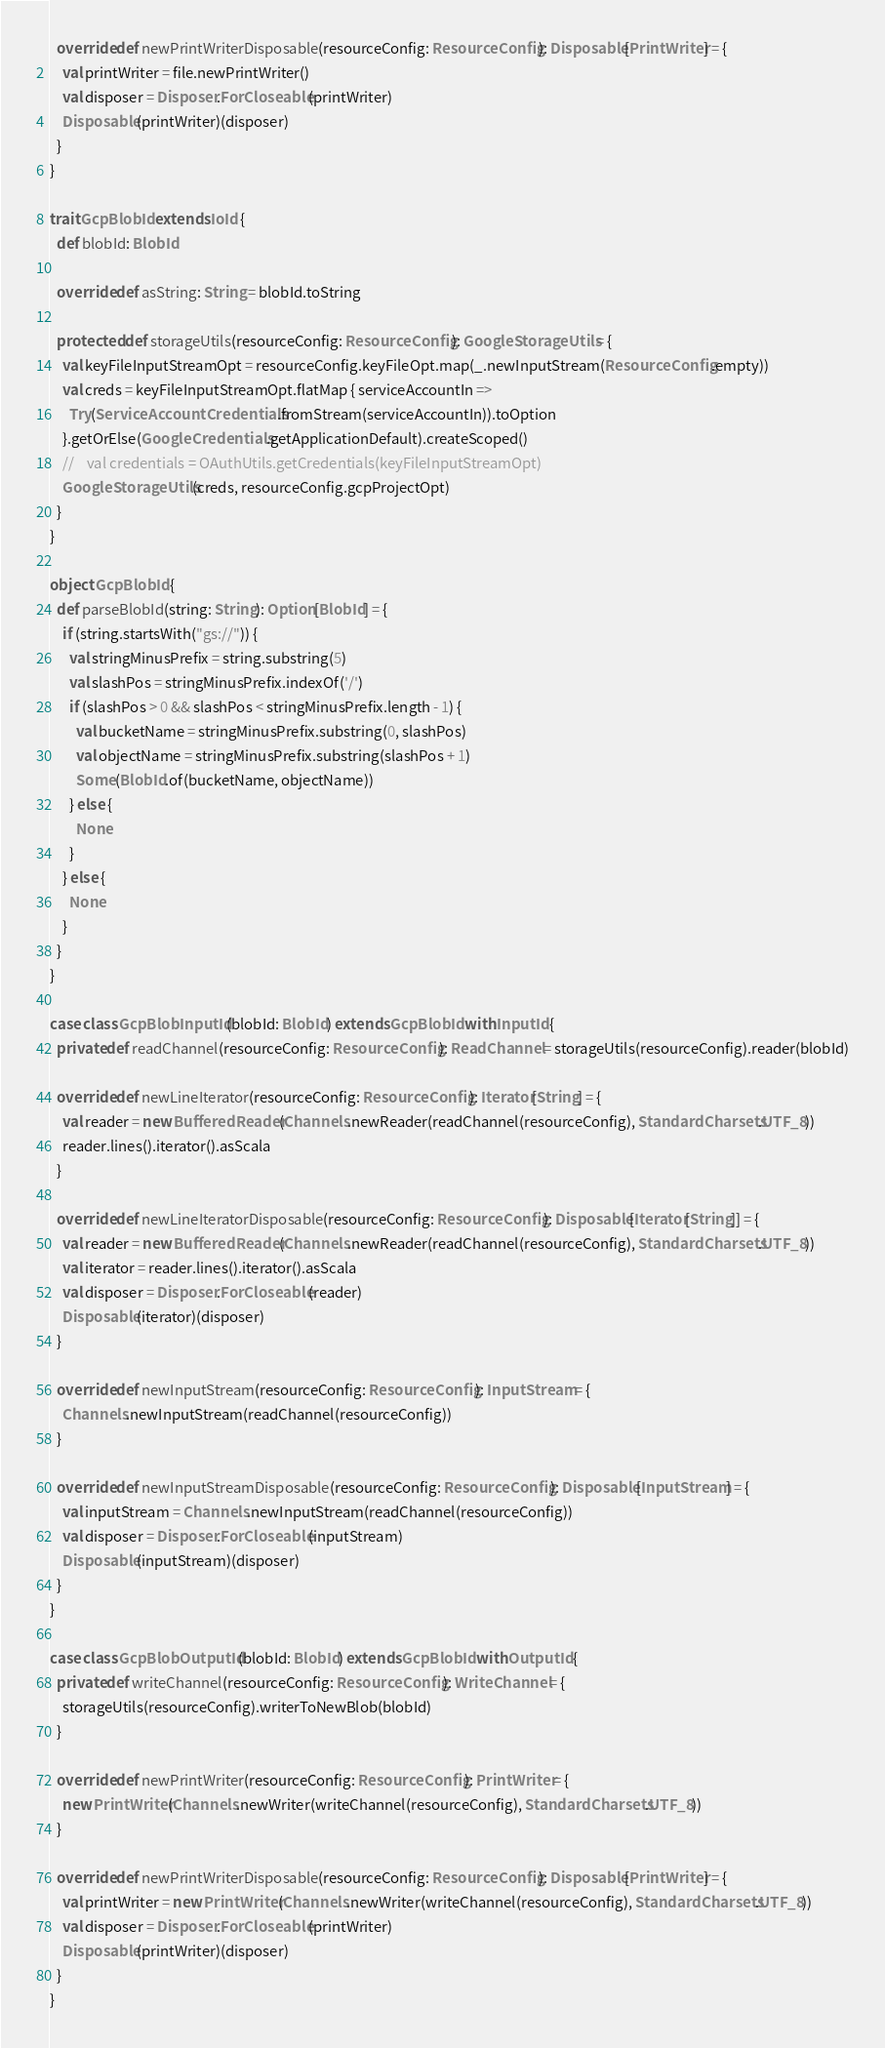Convert code to text. <code><loc_0><loc_0><loc_500><loc_500><_Scala_>
  override def newPrintWriterDisposable(resourceConfig: ResourceConfig): Disposable[PrintWriter] = {
    val printWriter = file.newPrintWriter()
    val disposer = Disposer.ForCloseable(printWriter)
    Disposable(printWriter)(disposer)
  }
}

trait GcpBlobId extends IoId {
  def blobId: BlobId

  override def asString: String = blobId.toString

  protected def storageUtils(resourceConfig: ResourceConfig): GoogleStorageUtils = {
    val keyFileInputStreamOpt = resourceConfig.keyFileOpt.map(_.newInputStream(ResourceConfig.empty))
    val creds = keyFileInputStreamOpt.flatMap { serviceAccountIn =>
      Try(ServiceAccountCredentials.fromStream(serviceAccountIn)).toOption
    }.getOrElse(GoogleCredentials.getApplicationDefault).createScoped()
    //    val credentials = OAuthUtils.getCredentials(keyFileInputStreamOpt)
    GoogleStorageUtils(creds, resourceConfig.gcpProjectOpt)
  }
}

object GcpBlobId {
  def parseBlobId(string: String): Option[BlobId] = {
    if (string.startsWith("gs://")) {
      val stringMinusPrefix = string.substring(5)
      val slashPos = stringMinusPrefix.indexOf('/')
      if (slashPos > 0 && slashPos < stringMinusPrefix.length - 1) {
        val bucketName = stringMinusPrefix.substring(0, slashPos)
        val objectName = stringMinusPrefix.substring(slashPos + 1)
        Some(BlobId.of(bucketName, objectName))
      } else {
        None
      }
    } else {
      None
    }
  }
}

case class GcpBlobInputId(blobId: BlobId) extends GcpBlobId with InputId {
  private def readChannel(resourceConfig: ResourceConfig): ReadChannel = storageUtils(resourceConfig).reader(blobId)

  override def newLineIterator(resourceConfig: ResourceConfig): Iterator[String] = {
    val reader = new BufferedReader(Channels.newReader(readChannel(resourceConfig), StandardCharsets.UTF_8))
    reader.lines().iterator().asScala
  }

  override def newLineIteratorDisposable(resourceConfig: ResourceConfig): Disposable[Iterator[String]] = {
    val reader = new BufferedReader(Channels.newReader(readChannel(resourceConfig), StandardCharsets.UTF_8))
    val iterator = reader.lines().iterator().asScala
    val disposer = Disposer.ForCloseable(reader)
    Disposable(iterator)(disposer)
  }

  override def newInputStream(resourceConfig: ResourceConfig): InputStream = {
    Channels.newInputStream(readChannel(resourceConfig))
  }

  override def newInputStreamDisposable(resourceConfig: ResourceConfig): Disposable[InputStream] = {
    val inputStream = Channels.newInputStream(readChannel(resourceConfig))
    val disposer = Disposer.ForCloseable(inputStream)
    Disposable(inputStream)(disposer)
  }
}

case class GcpBlobOutputId(blobId: BlobId) extends GcpBlobId with OutputId {
  private def writeChannel(resourceConfig: ResourceConfig): WriteChannel = {
    storageUtils(resourceConfig).writerToNewBlob(blobId)
  }

  override def newPrintWriter(resourceConfig: ResourceConfig): PrintWriter = {
    new PrintWriter(Channels.newWriter(writeChannel(resourceConfig), StandardCharsets.UTF_8))
  }

  override def newPrintWriterDisposable(resourceConfig: ResourceConfig): Disposable[PrintWriter] = {
    val printWriter = new PrintWriter(Channels.newWriter(writeChannel(resourceConfig), StandardCharsets.UTF_8))
    val disposer = Disposer.ForCloseable(printWriter)
    Disposable(printWriter)(disposer)
  }
}

</code> 